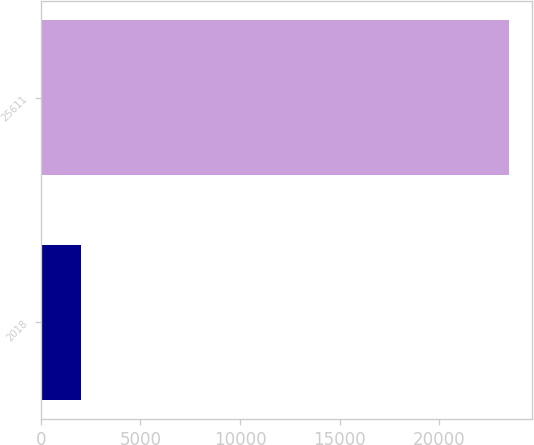Convert chart to OTSL. <chart><loc_0><loc_0><loc_500><loc_500><bar_chart><fcel>2018<fcel>25611<nl><fcel>2017<fcel>23473<nl></chart> 